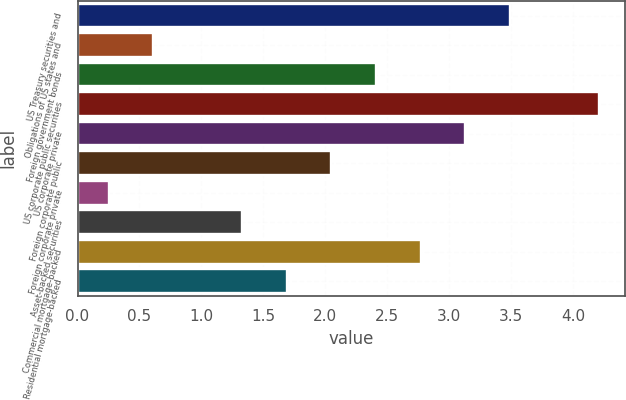<chart> <loc_0><loc_0><loc_500><loc_500><bar_chart><fcel>US Treasury securities and<fcel>Obligations of US states and<fcel>Foreign government bonds<fcel>US corporate public securities<fcel>US corporate private<fcel>Foreign corporate public<fcel>Foreign corporate private<fcel>Asset-backed securities<fcel>Commercial mortgage-backed<fcel>Residential mortgage-backed<nl><fcel>3.49<fcel>0.61<fcel>2.41<fcel>4.21<fcel>3.13<fcel>2.05<fcel>0.25<fcel>1.33<fcel>2.77<fcel>1.69<nl></chart> 